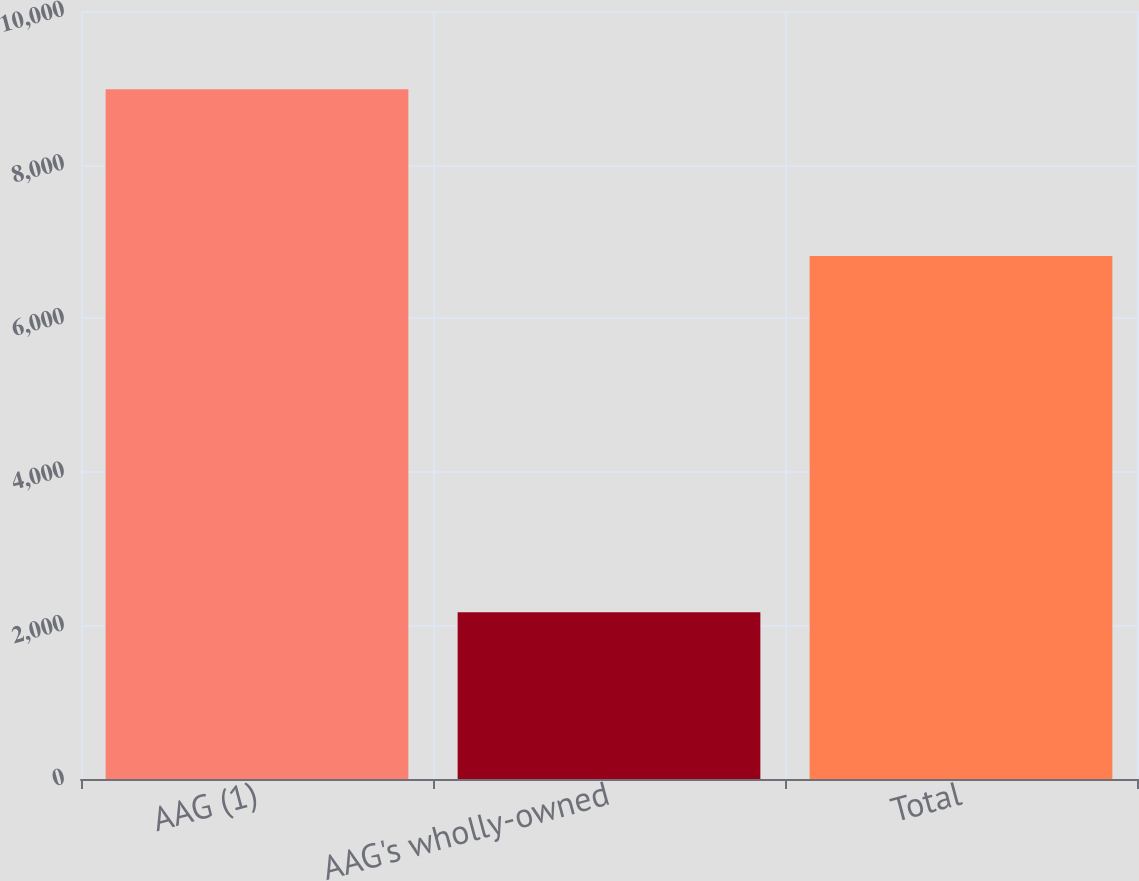Convert chart. <chart><loc_0><loc_0><loc_500><loc_500><bar_chart><fcel>AAG (1)<fcel>AAG's wholly-owned<fcel>Total<nl><fcel>8981<fcel>2171<fcel>6810<nl></chart> 